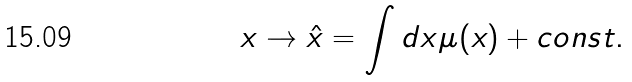<formula> <loc_0><loc_0><loc_500><loc_500>x \to \hat { x } = \int d x \mu ( x ) + c o n s t .</formula> 